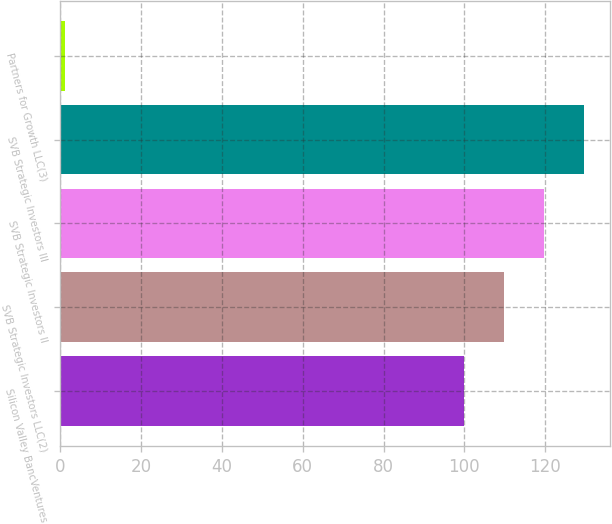Convert chart. <chart><loc_0><loc_0><loc_500><loc_500><bar_chart><fcel>Silicon Valley BancVentures<fcel>SVB Strategic Investors LLC(2)<fcel>SVB Strategic Investors II<fcel>SVB Strategic Investors III<fcel>Partners for Growth LLC(3)<nl><fcel>100<fcel>109.87<fcel>119.74<fcel>129.61<fcel>1.3<nl></chart> 